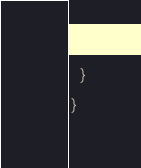Convert code to text. <code><loc_0><loc_0><loc_500><loc_500><_Scala_>  }
}
</code> 